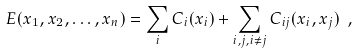Convert formula to latex. <formula><loc_0><loc_0><loc_500><loc_500>E ( x _ { 1 } , x _ { 2 } , \dots , x _ { n } ) = \sum _ { i } C _ { i } ( x _ { i } ) + \sum _ { i , j , i \not = j } C _ { i j } ( x _ { i } , x _ { j } ) \ ,</formula> 